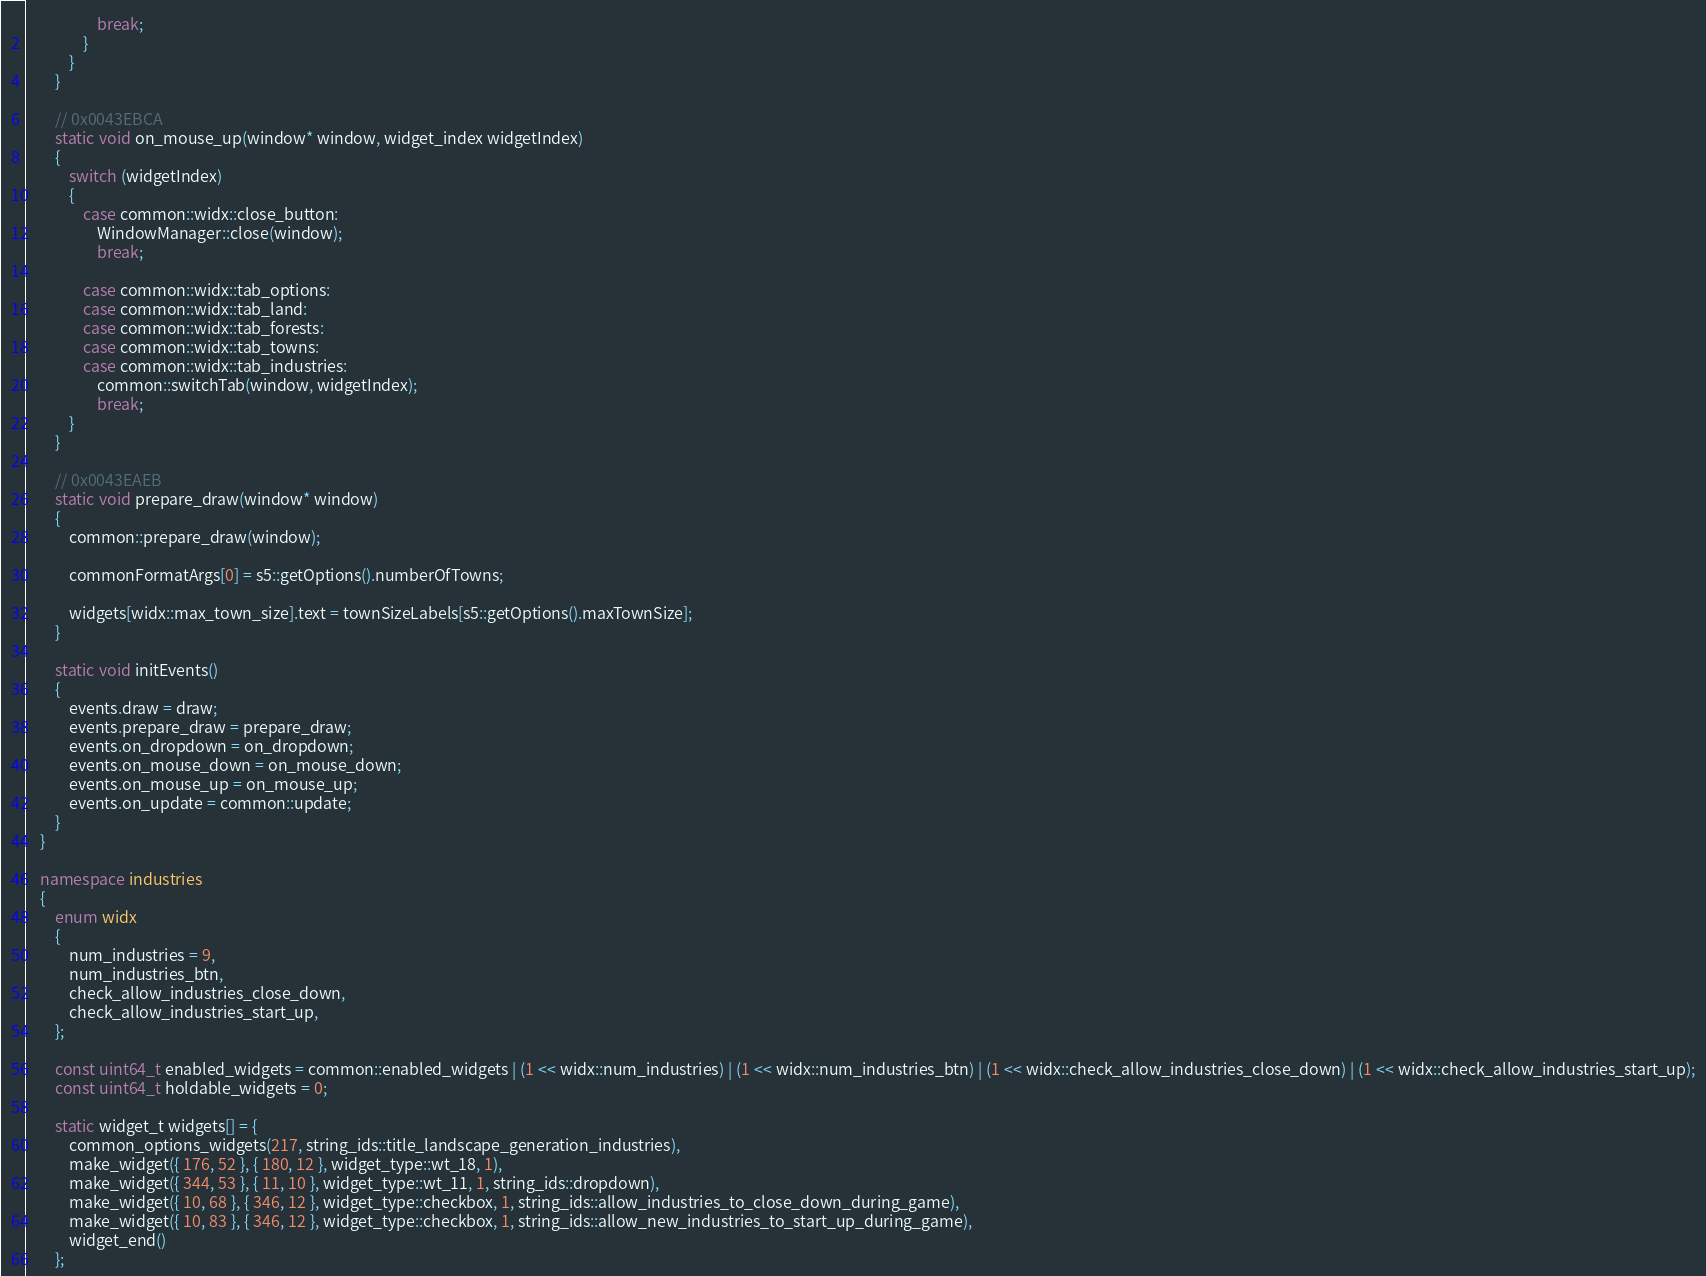Convert code to text. <code><loc_0><loc_0><loc_500><loc_500><_C++_>                    break;
                }
            }
        }

        // 0x0043EBCA
        static void on_mouse_up(window* window, widget_index widgetIndex)
        {
            switch (widgetIndex)
            {
                case common::widx::close_button:
                    WindowManager::close(window);
                    break;

                case common::widx::tab_options:
                case common::widx::tab_land:
                case common::widx::tab_forests:
                case common::widx::tab_towns:
                case common::widx::tab_industries:
                    common::switchTab(window, widgetIndex);
                    break;
            }
        }

        // 0x0043EAEB
        static void prepare_draw(window* window)
        {
            common::prepare_draw(window);

            commonFormatArgs[0] = s5::getOptions().numberOfTowns;

            widgets[widx::max_town_size].text = townSizeLabels[s5::getOptions().maxTownSize];
        }

        static void initEvents()
        {
            events.draw = draw;
            events.prepare_draw = prepare_draw;
            events.on_dropdown = on_dropdown;
            events.on_mouse_down = on_mouse_down;
            events.on_mouse_up = on_mouse_up;
            events.on_update = common::update;
        }
    }

    namespace industries
    {
        enum widx
        {
            num_industries = 9,
            num_industries_btn,
            check_allow_industries_close_down,
            check_allow_industries_start_up,
        };

        const uint64_t enabled_widgets = common::enabled_widgets | (1 << widx::num_industries) | (1 << widx::num_industries_btn) | (1 << widx::check_allow_industries_close_down) | (1 << widx::check_allow_industries_start_up);
        const uint64_t holdable_widgets = 0;

        static widget_t widgets[] = {
            common_options_widgets(217, string_ids::title_landscape_generation_industries),
            make_widget({ 176, 52 }, { 180, 12 }, widget_type::wt_18, 1),
            make_widget({ 344, 53 }, { 11, 10 }, widget_type::wt_11, 1, string_ids::dropdown),
            make_widget({ 10, 68 }, { 346, 12 }, widget_type::checkbox, 1, string_ids::allow_industries_to_close_down_during_game),
            make_widget({ 10, 83 }, { 346, 12 }, widget_type::checkbox, 1, string_ids::allow_new_industries_to_start_up_during_game),
            widget_end()
        };
</code> 